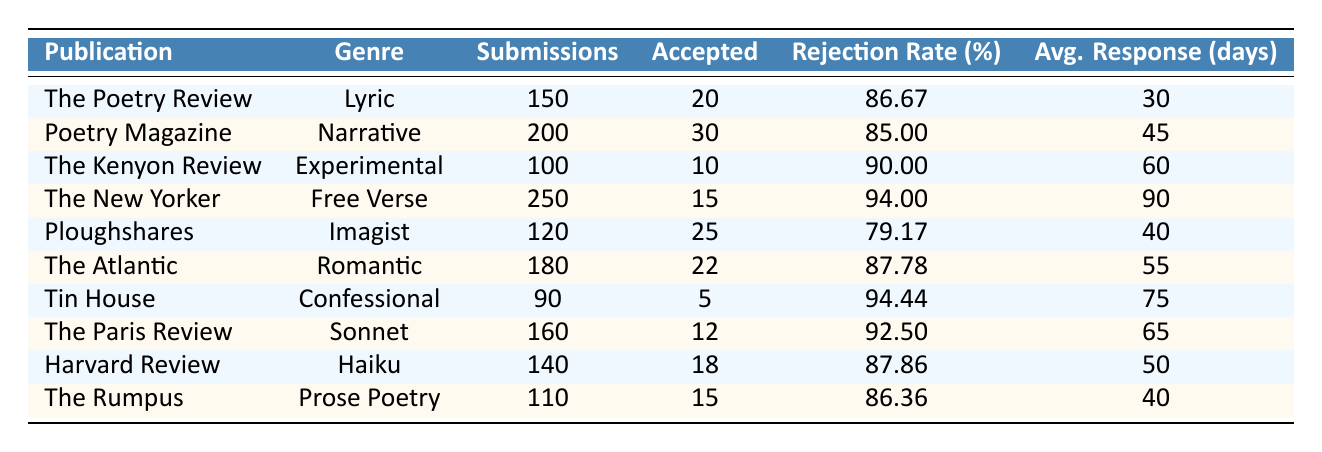What is the highest number of submissions for any publication? The publication with the highest submissions is "The New Yorker" with 250 submissions.
Answer: 250 Which genre has the lowest acceptance rate? To find the lowest acceptance rate, we compare the rejection rates since an acceptance rate of 100% minus the rejection rate gives the acceptance rate. "The New Yorker" has a rejection rate of 94.00%, leading to an acceptance rate of 6.00%, which is the lowest.
Answer: Free Verse What is the average response time across all publications? To calculate the average response time, sum all the average response times: (30 + 45 + 60 + 90 + 40 + 55 + 75 + 65 + 50 + 40) = 600, then divide by the number of publications (10), which is 600/10 = 60 days.
Answer: 60 days Is it true that "Ploughshares" has a lower rejection rate than "Harvard Review"? Ploughshares has a rejection rate of 79.17%, while Harvard Review has a rejection rate of 87.86%. Since 79.17% is lower than 87.86%, the statement is true.
Answer: Yes Which publication accepted the highest number of submissions? "Poetry Magazine" accepted the most submissions, with 30 accepted from 200 submissions.
Answer: 30 What is the total number of submissions for all genres combined? To find the total submissions, we sum all submissions: (150 + 200 + 100 + 250 + 120 + 180 + 90 + 160 + 140 + 110) = 1,400 submissions.
Answer: 1400 How does the rejection rate of "The Kenyon Review" compare to that of "Tin House"? "The Kenyon Review" has a rejection rate of 90.00%, while "Tin House" has a rejection rate of 94.44%. Thus, 90.00% is lower than 94.44%, indicating that "The Kenyon Review" has a better acceptance rate.
Answer: Lower What is the difference in the number of submissions between "The New Yorker" and "Tin House"? "The New Yorker" has 250 submissions and "Tin House" has 90. The difference is: 250 - 90 = 160 submissions.
Answer: 160 What is the genre with the least number of submissions? By comparing submissions, "Tin House" has the least with only 90 submissions.
Answer: Confessional Which publication had an average response time of 90 days? The publication with an average response time of 90 days is "The New Yorker".
Answer: The New Yorker 